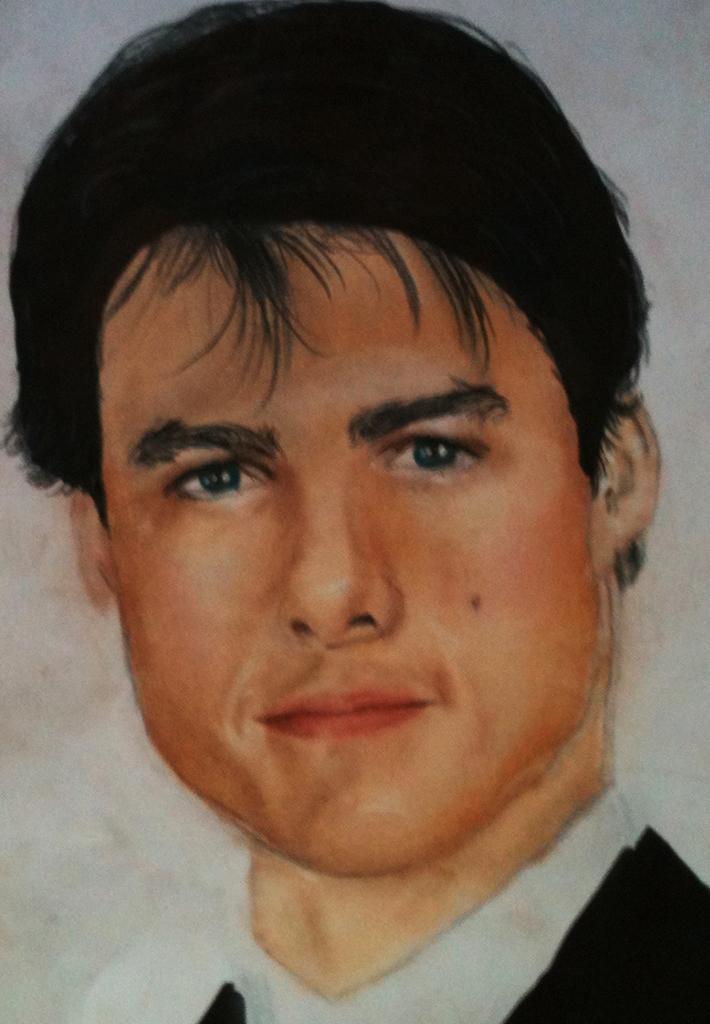Please provide a concise description of this image. This image consists of a painting of a man. He is wearing a black and white dress. In the background, we can see a wall. 